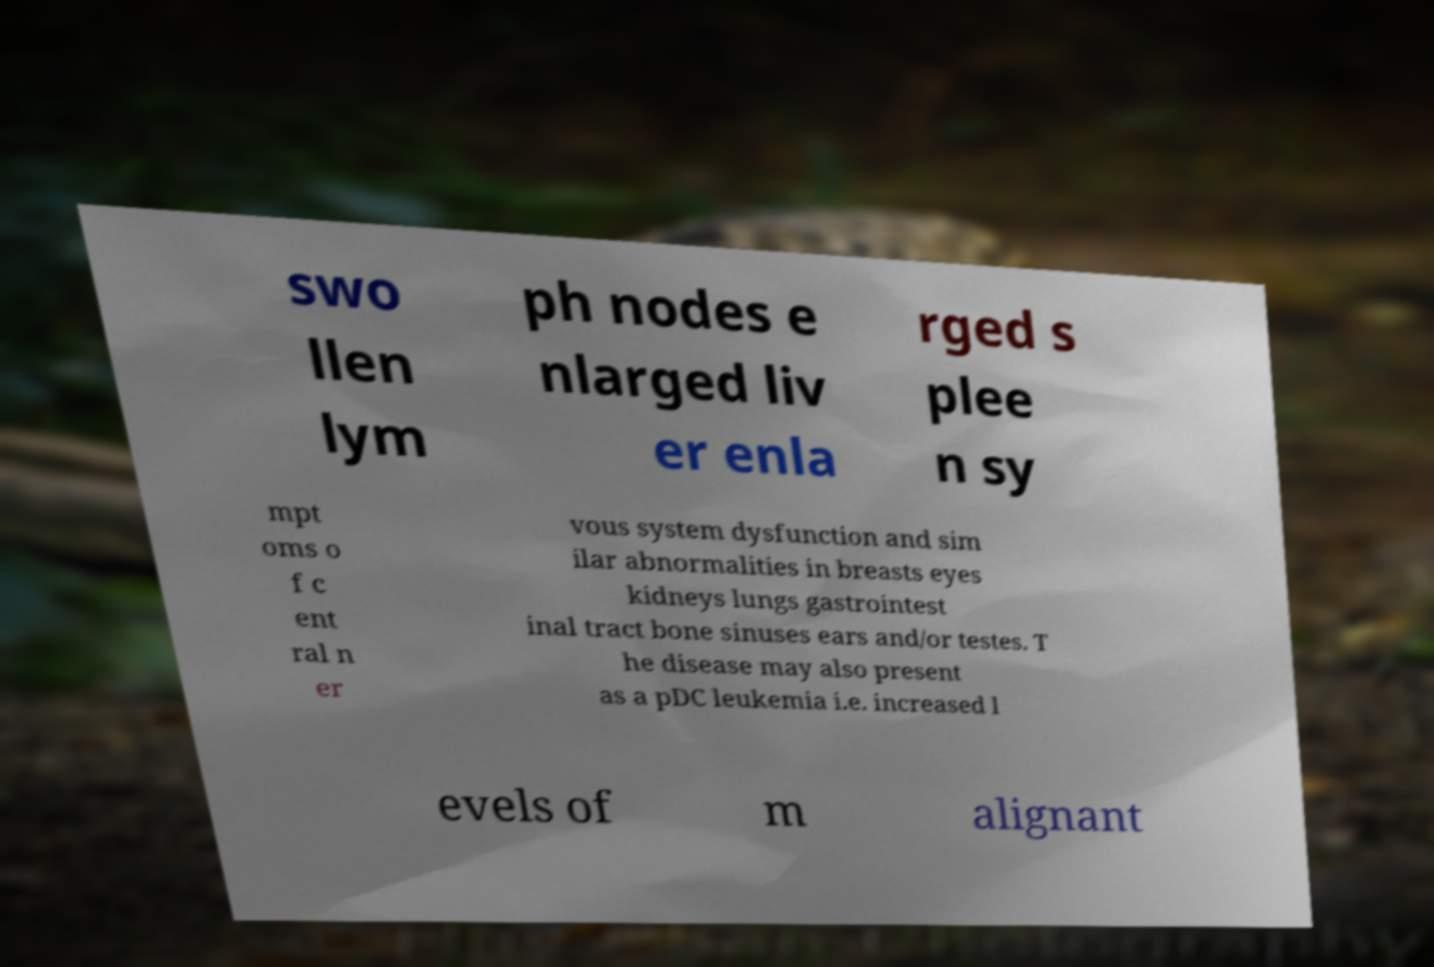Could you assist in decoding the text presented in this image and type it out clearly? swo llen lym ph nodes e nlarged liv er enla rged s plee n sy mpt oms o f c ent ral n er vous system dysfunction and sim ilar abnormalities in breasts eyes kidneys lungs gastrointest inal tract bone sinuses ears and/or testes. T he disease may also present as a pDC leukemia i.e. increased l evels of m alignant 